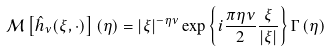Convert formula to latex. <formula><loc_0><loc_0><loc_500><loc_500>\mathcal { M } \left [ \hat { h } _ { \nu } ( \xi , \cdot ) \right ] ( \eta ) = | \xi | ^ { - \eta \nu } \exp \left \{ i \frac { \pi \eta \nu } { 2 } \frac { \xi } { | \xi | } \right \} \Gamma \left ( \eta \right )</formula> 